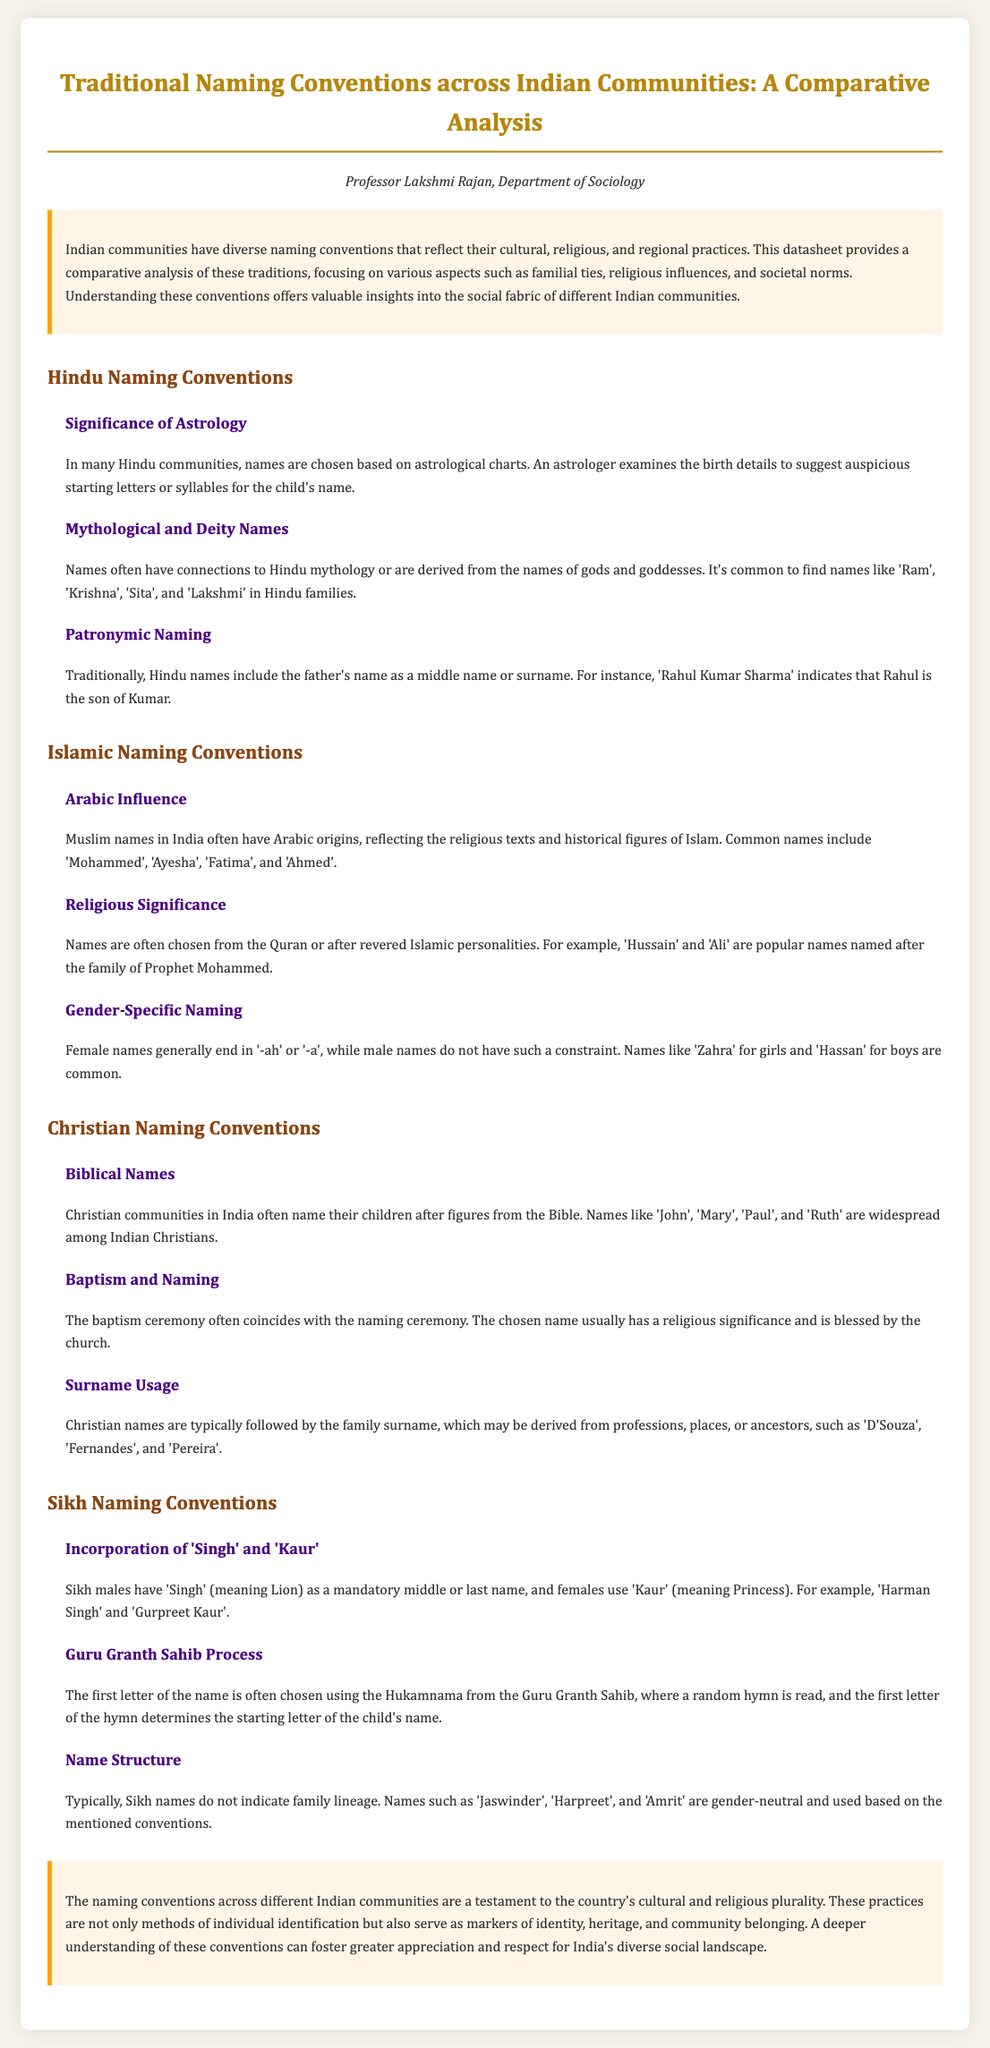What is the title of the document? The title is presented at the top of the document, indicating the main topic being discussed.
Answer: Traditional Naming Conventions across Indian Communities: A Comparative Analysis Who authored the document? The author information is provided below the title, giving credit for the work.
Answer: Professor Lakshmi Rajan What naming convention is emphasized in Hindu communities? The section on Hindu Naming Conventions highlights specific practices like astrological influences.
Answer: Astrology Which name is commonly used for Sikh females? In Sikh Naming Conventions, a specific name is mandated for females to indicate gender.
Answer: Kaur What is a popular male name among Islamic communities? The document provides examples of common names used in Muslim communities to represent naming practices.
Answer: Mohammed What letter selection method is used in Sikh naming? A specific process is described in the Sikh section regarding how names are chosen based on a scripture.
Answer: Hukamnama What biblical name is mentioned for Christians? The Christian Naming Conventions section provides examples of names derived from the Bible.
Answer: John How are most Christian surnames derived? The surname information explains the origins of surnames in Christian naming practices.
Answer: Professions, places, or ancestors 